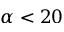Convert formula to latex. <formula><loc_0><loc_0><loc_500><loc_500>\alpha < 2 0</formula> 